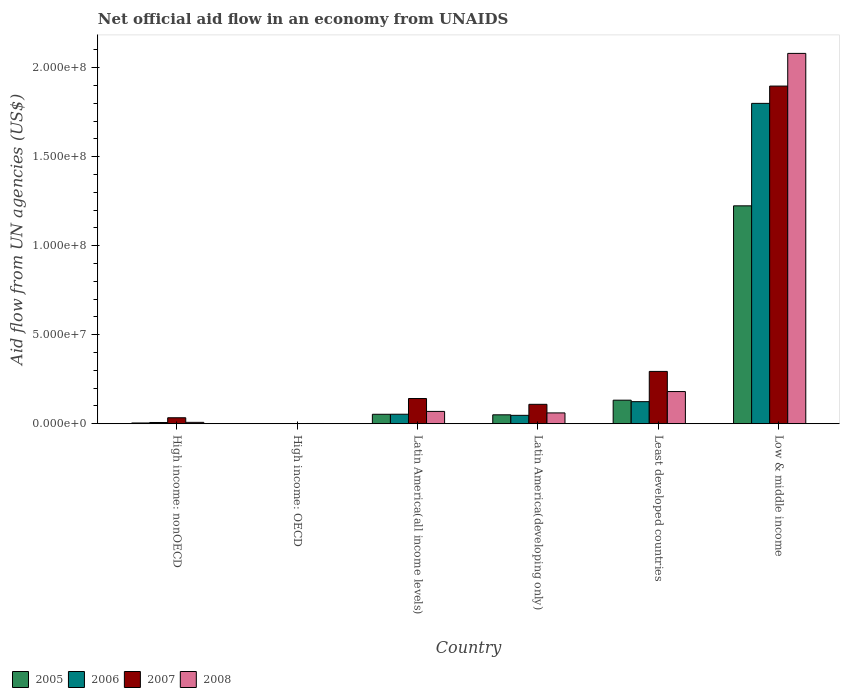Are the number of bars on each tick of the X-axis equal?
Your answer should be compact. Yes. How many bars are there on the 2nd tick from the left?
Your response must be concise. 4. How many bars are there on the 2nd tick from the right?
Give a very brief answer. 4. What is the label of the 3rd group of bars from the left?
Make the answer very short. Latin America(all income levels). Across all countries, what is the maximum net official aid flow in 2005?
Offer a very short reply. 1.22e+08. In which country was the net official aid flow in 2005 maximum?
Your answer should be very brief. Low & middle income. In which country was the net official aid flow in 2008 minimum?
Offer a terse response. High income: OECD. What is the total net official aid flow in 2008 in the graph?
Your answer should be very brief. 2.40e+08. What is the difference between the net official aid flow in 2008 in High income: nonOECD and that in Latin America(developing only)?
Ensure brevity in your answer.  -5.30e+06. What is the difference between the net official aid flow in 2008 in Low & middle income and the net official aid flow in 2006 in Least developed countries?
Offer a terse response. 1.96e+08. What is the average net official aid flow in 2006 per country?
Give a very brief answer. 3.39e+07. What is the difference between the net official aid flow of/in 2006 and net official aid flow of/in 2008 in Latin America(all income levels)?
Your answer should be very brief. -1.58e+06. What is the ratio of the net official aid flow in 2005 in High income: OECD to that in High income: nonOECD?
Your answer should be compact. 0.19. Is the net official aid flow in 2007 in Latin America(developing only) less than that in Least developed countries?
Your answer should be very brief. Yes. What is the difference between the highest and the second highest net official aid flow in 2008?
Make the answer very short. 1.90e+08. What is the difference between the highest and the lowest net official aid flow in 2005?
Ensure brevity in your answer.  1.22e+08. Is the sum of the net official aid flow in 2005 in High income: nonOECD and Least developed countries greater than the maximum net official aid flow in 2006 across all countries?
Offer a terse response. No. Is it the case that in every country, the sum of the net official aid flow in 2005 and net official aid flow in 2007 is greater than the sum of net official aid flow in 2008 and net official aid flow in 2006?
Keep it short and to the point. No. What does the 2nd bar from the left in High income: nonOECD represents?
Provide a short and direct response. 2006. Is it the case that in every country, the sum of the net official aid flow in 2008 and net official aid flow in 2007 is greater than the net official aid flow in 2005?
Offer a terse response. Yes. Are the values on the major ticks of Y-axis written in scientific E-notation?
Offer a very short reply. Yes. Does the graph contain grids?
Offer a terse response. No. Where does the legend appear in the graph?
Keep it short and to the point. Bottom left. How many legend labels are there?
Ensure brevity in your answer.  4. How are the legend labels stacked?
Provide a succinct answer. Horizontal. What is the title of the graph?
Make the answer very short. Net official aid flow in an economy from UNAIDS. Does "1976" appear as one of the legend labels in the graph?
Offer a very short reply. No. What is the label or title of the Y-axis?
Provide a short and direct response. Aid flow from UN agencies (US$). What is the Aid flow from UN agencies (US$) in 2007 in High income: nonOECD?
Keep it short and to the point. 3.36e+06. What is the Aid flow from UN agencies (US$) of 2008 in High income: nonOECD?
Offer a very short reply. 7.80e+05. What is the Aid flow from UN agencies (US$) in 2007 in High income: OECD?
Make the answer very short. 7.00e+04. What is the Aid flow from UN agencies (US$) of 2008 in High income: OECD?
Give a very brief answer. 1.40e+05. What is the Aid flow from UN agencies (US$) in 2005 in Latin America(all income levels)?
Give a very brief answer. 5.32e+06. What is the Aid flow from UN agencies (US$) in 2006 in Latin America(all income levels)?
Ensure brevity in your answer.  5.34e+06. What is the Aid flow from UN agencies (US$) of 2007 in Latin America(all income levels)?
Your response must be concise. 1.42e+07. What is the Aid flow from UN agencies (US$) in 2008 in Latin America(all income levels)?
Provide a succinct answer. 6.92e+06. What is the Aid flow from UN agencies (US$) in 2005 in Latin America(developing only)?
Provide a succinct answer. 5.01e+06. What is the Aid flow from UN agencies (US$) of 2006 in Latin America(developing only)?
Offer a terse response. 4.72e+06. What is the Aid flow from UN agencies (US$) of 2007 in Latin America(developing only)?
Provide a short and direct response. 1.09e+07. What is the Aid flow from UN agencies (US$) in 2008 in Latin America(developing only)?
Your answer should be very brief. 6.08e+06. What is the Aid flow from UN agencies (US$) in 2005 in Least developed countries?
Keep it short and to the point. 1.32e+07. What is the Aid flow from UN agencies (US$) of 2006 in Least developed countries?
Offer a very short reply. 1.24e+07. What is the Aid flow from UN agencies (US$) in 2007 in Least developed countries?
Keep it short and to the point. 2.94e+07. What is the Aid flow from UN agencies (US$) of 2008 in Least developed countries?
Provide a succinct answer. 1.81e+07. What is the Aid flow from UN agencies (US$) of 2005 in Low & middle income?
Give a very brief answer. 1.22e+08. What is the Aid flow from UN agencies (US$) in 2006 in Low & middle income?
Give a very brief answer. 1.80e+08. What is the Aid flow from UN agencies (US$) of 2007 in Low & middle income?
Make the answer very short. 1.90e+08. What is the Aid flow from UN agencies (US$) in 2008 in Low & middle income?
Your answer should be very brief. 2.08e+08. Across all countries, what is the maximum Aid flow from UN agencies (US$) of 2005?
Provide a short and direct response. 1.22e+08. Across all countries, what is the maximum Aid flow from UN agencies (US$) in 2006?
Your answer should be compact. 1.80e+08. Across all countries, what is the maximum Aid flow from UN agencies (US$) of 2007?
Provide a succinct answer. 1.90e+08. Across all countries, what is the maximum Aid flow from UN agencies (US$) in 2008?
Your response must be concise. 2.08e+08. Across all countries, what is the minimum Aid flow from UN agencies (US$) in 2005?
Your answer should be very brief. 8.00e+04. Across all countries, what is the minimum Aid flow from UN agencies (US$) of 2007?
Provide a short and direct response. 7.00e+04. Across all countries, what is the minimum Aid flow from UN agencies (US$) in 2008?
Ensure brevity in your answer.  1.40e+05. What is the total Aid flow from UN agencies (US$) in 2005 in the graph?
Give a very brief answer. 1.46e+08. What is the total Aid flow from UN agencies (US$) in 2006 in the graph?
Your answer should be very brief. 2.03e+08. What is the total Aid flow from UN agencies (US$) of 2007 in the graph?
Offer a very short reply. 2.48e+08. What is the total Aid flow from UN agencies (US$) in 2008 in the graph?
Your answer should be compact. 2.40e+08. What is the difference between the Aid flow from UN agencies (US$) in 2005 in High income: nonOECD and that in High income: OECD?
Offer a very short reply. 3.50e+05. What is the difference between the Aid flow from UN agencies (US$) of 2006 in High income: nonOECD and that in High income: OECD?
Provide a short and direct response. 6.70e+05. What is the difference between the Aid flow from UN agencies (US$) in 2007 in High income: nonOECD and that in High income: OECD?
Your response must be concise. 3.29e+06. What is the difference between the Aid flow from UN agencies (US$) of 2008 in High income: nonOECD and that in High income: OECD?
Provide a short and direct response. 6.40e+05. What is the difference between the Aid flow from UN agencies (US$) of 2005 in High income: nonOECD and that in Latin America(all income levels)?
Provide a succinct answer. -4.89e+06. What is the difference between the Aid flow from UN agencies (US$) of 2006 in High income: nonOECD and that in Latin America(all income levels)?
Provide a short and direct response. -4.64e+06. What is the difference between the Aid flow from UN agencies (US$) of 2007 in High income: nonOECD and that in Latin America(all income levels)?
Provide a short and direct response. -1.08e+07. What is the difference between the Aid flow from UN agencies (US$) in 2008 in High income: nonOECD and that in Latin America(all income levels)?
Offer a very short reply. -6.14e+06. What is the difference between the Aid flow from UN agencies (US$) in 2005 in High income: nonOECD and that in Latin America(developing only)?
Your response must be concise. -4.58e+06. What is the difference between the Aid flow from UN agencies (US$) of 2006 in High income: nonOECD and that in Latin America(developing only)?
Your answer should be compact. -4.02e+06. What is the difference between the Aid flow from UN agencies (US$) of 2007 in High income: nonOECD and that in Latin America(developing only)?
Ensure brevity in your answer.  -7.55e+06. What is the difference between the Aid flow from UN agencies (US$) of 2008 in High income: nonOECD and that in Latin America(developing only)?
Your response must be concise. -5.30e+06. What is the difference between the Aid flow from UN agencies (US$) in 2005 in High income: nonOECD and that in Least developed countries?
Ensure brevity in your answer.  -1.28e+07. What is the difference between the Aid flow from UN agencies (US$) of 2006 in High income: nonOECD and that in Least developed countries?
Provide a short and direct response. -1.17e+07. What is the difference between the Aid flow from UN agencies (US$) in 2007 in High income: nonOECD and that in Least developed countries?
Your answer should be very brief. -2.60e+07. What is the difference between the Aid flow from UN agencies (US$) of 2008 in High income: nonOECD and that in Least developed countries?
Your answer should be very brief. -1.73e+07. What is the difference between the Aid flow from UN agencies (US$) in 2005 in High income: nonOECD and that in Low & middle income?
Ensure brevity in your answer.  -1.22e+08. What is the difference between the Aid flow from UN agencies (US$) in 2006 in High income: nonOECD and that in Low & middle income?
Your response must be concise. -1.79e+08. What is the difference between the Aid flow from UN agencies (US$) of 2007 in High income: nonOECD and that in Low & middle income?
Keep it short and to the point. -1.86e+08. What is the difference between the Aid flow from UN agencies (US$) in 2008 in High income: nonOECD and that in Low & middle income?
Provide a succinct answer. -2.07e+08. What is the difference between the Aid flow from UN agencies (US$) in 2005 in High income: OECD and that in Latin America(all income levels)?
Your answer should be compact. -5.24e+06. What is the difference between the Aid flow from UN agencies (US$) in 2006 in High income: OECD and that in Latin America(all income levels)?
Your response must be concise. -5.31e+06. What is the difference between the Aid flow from UN agencies (US$) in 2007 in High income: OECD and that in Latin America(all income levels)?
Offer a very short reply. -1.41e+07. What is the difference between the Aid flow from UN agencies (US$) in 2008 in High income: OECD and that in Latin America(all income levels)?
Your answer should be very brief. -6.78e+06. What is the difference between the Aid flow from UN agencies (US$) of 2005 in High income: OECD and that in Latin America(developing only)?
Provide a succinct answer. -4.93e+06. What is the difference between the Aid flow from UN agencies (US$) of 2006 in High income: OECD and that in Latin America(developing only)?
Your response must be concise. -4.69e+06. What is the difference between the Aid flow from UN agencies (US$) of 2007 in High income: OECD and that in Latin America(developing only)?
Offer a terse response. -1.08e+07. What is the difference between the Aid flow from UN agencies (US$) in 2008 in High income: OECD and that in Latin America(developing only)?
Provide a short and direct response. -5.94e+06. What is the difference between the Aid flow from UN agencies (US$) in 2005 in High income: OECD and that in Least developed countries?
Provide a succinct answer. -1.32e+07. What is the difference between the Aid flow from UN agencies (US$) of 2006 in High income: OECD and that in Least developed countries?
Your answer should be compact. -1.24e+07. What is the difference between the Aid flow from UN agencies (US$) of 2007 in High income: OECD and that in Least developed countries?
Give a very brief answer. -2.93e+07. What is the difference between the Aid flow from UN agencies (US$) in 2008 in High income: OECD and that in Least developed countries?
Provide a succinct answer. -1.79e+07. What is the difference between the Aid flow from UN agencies (US$) in 2005 in High income: OECD and that in Low & middle income?
Provide a short and direct response. -1.22e+08. What is the difference between the Aid flow from UN agencies (US$) of 2006 in High income: OECD and that in Low & middle income?
Offer a very short reply. -1.80e+08. What is the difference between the Aid flow from UN agencies (US$) of 2007 in High income: OECD and that in Low & middle income?
Provide a short and direct response. -1.90e+08. What is the difference between the Aid flow from UN agencies (US$) in 2008 in High income: OECD and that in Low & middle income?
Provide a short and direct response. -2.08e+08. What is the difference between the Aid flow from UN agencies (US$) in 2006 in Latin America(all income levels) and that in Latin America(developing only)?
Keep it short and to the point. 6.20e+05. What is the difference between the Aid flow from UN agencies (US$) of 2007 in Latin America(all income levels) and that in Latin America(developing only)?
Make the answer very short. 3.25e+06. What is the difference between the Aid flow from UN agencies (US$) of 2008 in Latin America(all income levels) and that in Latin America(developing only)?
Keep it short and to the point. 8.40e+05. What is the difference between the Aid flow from UN agencies (US$) in 2005 in Latin America(all income levels) and that in Least developed countries?
Keep it short and to the point. -7.91e+06. What is the difference between the Aid flow from UN agencies (US$) of 2006 in Latin America(all income levels) and that in Least developed countries?
Keep it short and to the point. -7.06e+06. What is the difference between the Aid flow from UN agencies (US$) in 2007 in Latin America(all income levels) and that in Least developed countries?
Offer a very short reply. -1.52e+07. What is the difference between the Aid flow from UN agencies (US$) in 2008 in Latin America(all income levels) and that in Least developed countries?
Offer a very short reply. -1.12e+07. What is the difference between the Aid flow from UN agencies (US$) of 2005 in Latin America(all income levels) and that in Low & middle income?
Give a very brief answer. -1.17e+08. What is the difference between the Aid flow from UN agencies (US$) of 2006 in Latin America(all income levels) and that in Low & middle income?
Ensure brevity in your answer.  -1.75e+08. What is the difference between the Aid flow from UN agencies (US$) in 2007 in Latin America(all income levels) and that in Low & middle income?
Your response must be concise. -1.76e+08. What is the difference between the Aid flow from UN agencies (US$) in 2008 in Latin America(all income levels) and that in Low & middle income?
Your response must be concise. -2.01e+08. What is the difference between the Aid flow from UN agencies (US$) in 2005 in Latin America(developing only) and that in Least developed countries?
Your response must be concise. -8.22e+06. What is the difference between the Aid flow from UN agencies (US$) of 2006 in Latin America(developing only) and that in Least developed countries?
Provide a succinct answer. -7.68e+06. What is the difference between the Aid flow from UN agencies (US$) of 2007 in Latin America(developing only) and that in Least developed countries?
Keep it short and to the point. -1.85e+07. What is the difference between the Aid flow from UN agencies (US$) in 2008 in Latin America(developing only) and that in Least developed countries?
Offer a very short reply. -1.20e+07. What is the difference between the Aid flow from UN agencies (US$) of 2005 in Latin America(developing only) and that in Low & middle income?
Give a very brief answer. -1.17e+08. What is the difference between the Aid flow from UN agencies (US$) in 2006 in Latin America(developing only) and that in Low & middle income?
Provide a short and direct response. -1.75e+08. What is the difference between the Aid flow from UN agencies (US$) in 2007 in Latin America(developing only) and that in Low & middle income?
Provide a succinct answer. -1.79e+08. What is the difference between the Aid flow from UN agencies (US$) in 2008 in Latin America(developing only) and that in Low & middle income?
Your answer should be very brief. -2.02e+08. What is the difference between the Aid flow from UN agencies (US$) in 2005 in Least developed countries and that in Low & middle income?
Ensure brevity in your answer.  -1.09e+08. What is the difference between the Aid flow from UN agencies (US$) in 2006 in Least developed countries and that in Low & middle income?
Provide a short and direct response. -1.68e+08. What is the difference between the Aid flow from UN agencies (US$) in 2007 in Least developed countries and that in Low & middle income?
Keep it short and to the point. -1.60e+08. What is the difference between the Aid flow from UN agencies (US$) in 2008 in Least developed countries and that in Low & middle income?
Offer a terse response. -1.90e+08. What is the difference between the Aid flow from UN agencies (US$) in 2005 in High income: nonOECD and the Aid flow from UN agencies (US$) in 2006 in High income: OECD?
Your response must be concise. 4.00e+05. What is the difference between the Aid flow from UN agencies (US$) of 2005 in High income: nonOECD and the Aid flow from UN agencies (US$) of 2008 in High income: OECD?
Make the answer very short. 2.90e+05. What is the difference between the Aid flow from UN agencies (US$) of 2006 in High income: nonOECD and the Aid flow from UN agencies (US$) of 2007 in High income: OECD?
Provide a succinct answer. 6.30e+05. What is the difference between the Aid flow from UN agencies (US$) of 2006 in High income: nonOECD and the Aid flow from UN agencies (US$) of 2008 in High income: OECD?
Make the answer very short. 5.60e+05. What is the difference between the Aid flow from UN agencies (US$) in 2007 in High income: nonOECD and the Aid flow from UN agencies (US$) in 2008 in High income: OECD?
Offer a terse response. 3.22e+06. What is the difference between the Aid flow from UN agencies (US$) of 2005 in High income: nonOECD and the Aid flow from UN agencies (US$) of 2006 in Latin America(all income levels)?
Provide a succinct answer. -4.91e+06. What is the difference between the Aid flow from UN agencies (US$) of 2005 in High income: nonOECD and the Aid flow from UN agencies (US$) of 2007 in Latin America(all income levels)?
Your response must be concise. -1.37e+07. What is the difference between the Aid flow from UN agencies (US$) of 2005 in High income: nonOECD and the Aid flow from UN agencies (US$) of 2008 in Latin America(all income levels)?
Provide a short and direct response. -6.49e+06. What is the difference between the Aid flow from UN agencies (US$) in 2006 in High income: nonOECD and the Aid flow from UN agencies (US$) in 2007 in Latin America(all income levels)?
Provide a short and direct response. -1.35e+07. What is the difference between the Aid flow from UN agencies (US$) in 2006 in High income: nonOECD and the Aid flow from UN agencies (US$) in 2008 in Latin America(all income levels)?
Offer a very short reply. -6.22e+06. What is the difference between the Aid flow from UN agencies (US$) in 2007 in High income: nonOECD and the Aid flow from UN agencies (US$) in 2008 in Latin America(all income levels)?
Your response must be concise. -3.56e+06. What is the difference between the Aid flow from UN agencies (US$) of 2005 in High income: nonOECD and the Aid flow from UN agencies (US$) of 2006 in Latin America(developing only)?
Ensure brevity in your answer.  -4.29e+06. What is the difference between the Aid flow from UN agencies (US$) of 2005 in High income: nonOECD and the Aid flow from UN agencies (US$) of 2007 in Latin America(developing only)?
Give a very brief answer. -1.05e+07. What is the difference between the Aid flow from UN agencies (US$) of 2005 in High income: nonOECD and the Aid flow from UN agencies (US$) of 2008 in Latin America(developing only)?
Make the answer very short. -5.65e+06. What is the difference between the Aid flow from UN agencies (US$) in 2006 in High income: nonOECD and the Aid flow from UN agencies (US$) in 2007 in Latin America(developing only)?
Provide a succinct answer. -1.02e+07. What is the difference between the Aid flow from UN agencies (US$) of 2006 in High income: nonOECD and the Aid flow from UN agencies (US$) of 2008 in Latin America(developing only)?
Your answer should be very brief. -5.38e+06. What is the difference between the Aid flow from UN agencies (US$) of 2007 in High income: nonOECD and the Aid flow from UN agencies (US$) of 2008 in Latin America(developing only)?
Keep it short and to the point. -2.72e+06. What is the difference between the Aid flow from UN agencies (US$) in 2005 in High income: nonOECD and the Aid flow from UN agencies (US$) in 2006 in Least developed countries?
Ensure brevity in your answer.  -1.20e+07. What is the difference between the Aid flow from UN agencies (US$) of 2005 in High income: nonOECD and the Aid flow from UN agencies (US$) of 2007 in Least developed countries?
Offer a terse response. -2.90e+07. What is the difference between the Aid flow from UN agencies (US$) in 2005 in High income: nonOECD and the Aid flow from UN agencies (US$) in 2008 in Least developed countries?
Provide a succinct answer. -1.76e+07. What is the difference between the Aid flow from UN agencies (US$) in 2006 in High income: nonOECD and the Aid flow from UN agencies (US$) in 2007 in Least developed countries?
Ensure brevity in your answer.  -2.87e+07. What is the difference between the Aid flow from UN agencies (US$) in 2006 in High income: nonOECD and the Aid flow from UN agencies (US$) in 2008 in Least developed countries?
Provide a short and direct response. -1.74e+07. What is the difference between the Aid flow from UN agencies (US$) of 2007 in High income: nonOECD and the Aid flow from UN agencies (US$) of 2008 in Least developed countries?
Provide a short and direct response. -1.47e+07. What is the difference between the Aid flow from UN agencies (US$) of 2005 in High income: nonOECD and the Aid flow from UN agencies (US$) of 2006 in Low & middle income?
Give a very brief answer. -1.80e+08. What is the difference between the Aid flow from UN agencies (US$) of 2005 in High income: nonOECD and the Aid flow from UN agencies (US$) of 2007 in Low & middle income?
Your answer should be very brief. -1.89e+08. What is the difference between the Aid flow from UN agencies (US$) of 2005 in High income: nonOECD and the Aid flow from UN agencies (US$) of 2008 in Low & middle income?
Provide a short and direct response. -2.08e+08. What is the difference between the Aid flow from UN agencies (US$) of 2006 in High income: nonOECD and the Aid flow from UN agencies (US$) of 2007 in Low & middle income?
Ensure brevity in your answer.  -1.89e+08. What is the difference between the Aid flow from UN agencies (US$) in 2006 in High income: nonOECD and the Aid flow from UN agencies (US$) in 2008 in Low & middle income?
Provide a short and direct response. -2.07e+08. What is the difference between the Aid flow from UN agencies (US$) in 2007 in High income: nonOECD and the Aid flow from UN agencies (US$) in 2008 in Low & middle income?
Make the answer very short. -2.05e+08. What is the difference between the Aid flow from UN agencies (US$) of 2005 in High income: OECD and the Aid flow from UN agencies (US$) of 2006 in Latin America(all income levels)?
Make the answer very short. -5.26e+06. What is the difference between the Aid flow from UN agencies (US$) in 2005 in High income: OECD and the Aid flow from UN agencies (US$) in 2007 in Latin America(all income levels)?
Offer a very short reply. -1.41e+07. What is the difference between the Aid flow from UN agencies (US$) in 2005 in High income: OECD and the Aid flow from UN agencies (US$) in 2008 in Latin America(all income levels)?
Ensure brevity in your answer.  -6.84e+06. What is the difference between the Aid flow from UN agencies (US$) in 2006 in High income: OECD and the Aid flow from UN agencies (US$) in 2007 in Latin America(all income levels)?
Your answer should be very brief. -1.41e+07. What is the difference between the Aid flow from UN agencies (US$) of 2006 in High income: OECD and the Aid flow from UN agencies (US$) of 2008 in Latin America(all income levels)?
Your answer should be compact. -6.89e+06. What is the difference between the Aid flow from UN agencies (US$) of 2007 in High income: OECD and the Aid flow from UN agencies (US$) of 2008 in Latin America(all income levels)?
Give a very brief answer. -6.85e+06. What is the difference between the Aid flow from UN agencies (US$) of 2005 in High income: OECD and the Aid flow from UN agencies (US$) of 2006 in Latin America(developing only)?
Make the answer very short. -4.64e+06. What is the difference between the Aid flow from UN agencies (US$) in 2005 in High income: OECD and the Aid flow from UN agencies (US$) in 2007 in Latin America(developing only)?
Provide a succinct answer. -1.08e+07. What is the difference between the Aid flow from UN agencies (US$) in 2005 in High income: OECD and the Aid flow from UN agencies (US$) in 2008 in Latin America(developing only)?
Provide a succinct answer. -6.00e+06. What is the difference between the Aid flow from UN agencies (US$) of 2006 in High income: OECD and the Aid flow from UN agencies (US$) of 2007 in Latin America(developing only)?
Your response must be concise. -1.09e+07. What is the difference between the Aid flow from UN agencies (US$) in 2006 in High income: OECD and the Aid flow from UN agencies (US$) in 2008 in Latin America(developing only)?
Offer a very short reply. -6.05e+06. What is the difference between the Aid flow from UN agencies (US$) of 2007 in High income: OECD and the Aid flow from UN agencies (US$) of 2008 in Latin America(developing only)?
Your response must be concise. -6.01e+06. What is the difference between the Aid flow from UN agencies (US$) of 2005 in High income: OECD and the Aid flow from UN agencies (US$) of 2006 in Least developed countries?
Your response must be concise. -1.23e+07. What is the difference between the Aid flow from UN agencies (US$) in 2005 in High income: OECD and the Aid flow from UN agencies (US$) in 2007 in Least developed countries?
Make the answer very short. -2.93e+07. What is the difference between the Aid flow from UN agencies (US$) of 2005 in High income: OECD and the Aid flow from UN agencies (US$) of 2008 in Least developed countries?
Offer a very short reply. -1.80e+07. What is the difference between the Aid flow from UN agencies (US$) of 2006 in High income: OECD and the Aid flow from UN agencies (US$) of 2007 in Least developed countries?
Keep it short and to the point. -2.94e+07. What is the difference between the Aid flow from UN agencies (US$) of 2006 in High income: OECD and the Aid flow from UN agencies (US$) of 2008 in Least developed countries?
Provide a succinct answer. -1.80e+07. What is the difference between the Aid flow from UN agencies (US$) in 2007 in High income: OECD and the Aid flow from UN agencies (US$) in 2008 in Least developed countries?
Your response must be concise. -1.80e+07. What is the difference between the Aid flow from UN agencies (US$) of 2005 in High income: OECD and the Aid flow from UN agencies (US$) of 2006 in Low & middle income?
Keep it short and to the point. -1.80e+08. What is the difference between the Aid flow from UN agencies (US$) in 2005 in High income: OECD and the Aid flow from UN agencies (US$) in 2007 in Low & middle income?
Provide a succinct answer. -1.90e+08. What is the difference between the Aid flow from UN agencies (US$) in 2005 in High income: OECD and the Aid flow from UN agencies (US$) in 2008 in Low & middle income?
Provide a short and direct response. -2.08e+08. What is the difference between the Aid flow from UN agencies (US$) of 2006 in High income: OECD and the Aid flow from UN agencies (US$) of 2007 in Low & middle income?
Your response must be concise. -1.90e+08. What is the difference between the Aid flow from UN agencies (US$) of 2006 in High income: OECD and the Aid flow from UN agencies (US$) of 2008 in Low & middle income?
Keep it short and to the point. -2.08e+08. What is the difference between the Aid flow from UN agencies (US$) in 2007 in High income: OECD and the Aid flow from UN agencies (US$) in 2008 in Low & middle income?
Ensure brevity in your answer.  -2.08e+08. What is the difference between the Aid flow from UN agencies (US$) in 2005 in Latin America(all income levels) and the Aid flow from UN agencies (US$) in 2006 in Latin America(developing only)?
Keep it short and to the point. 6.00e+05. What is the difference between the Aid flow from UN agencies (US$) of 2005 in Latin America(all income levels) and the Aid flow from UN agencies (US$) of 2007 in Latin America(developing only)?
Provide a succinct answer. -5.59e+06. What is the difference between the Aid flow from UN agencies (US$) in 2005 in Latin America(all income levels) and the Aid flow from UN agencies (US$) in 2008 in Latin America(developing only)?
Make the answer very short. -7.60e+05. What is the difference between the Aid flow from UN agencies (US$) in 2006 in Latin America(all income levels) and the Aid flow from UN agencies (US$) in 2007 in Latin America(developing only)?
Keep it short and to the point. -5.57e+06. What is the difference between the Aid flow from UN agencies (US$) in 2006 in Latin America(all income levels) and the Aid flow from UN agencies (US$) in 2008 in Latin America(developing only)?
Ensure brevity in your answer.  -7.40e+05. What is the difference between the Aid flow from UN agencies (US$) of 2007 in Latin America(all income levels) and the Aid flow from UN agencies (US$) of 2008 in Latin America(developing only)?
Give a very brief answer. 8.08e+06. What is the difference between the Aid flow from UN agencies (US$) in 2005 in Latin America(all income levels) and the Aid flow from UN agencies (US$) in 2006 in Least developed countries?
Your response must be concise. -7.08e+06. What is the difference between the Aid flow from UN agencies (US$) in 2005 in Latin America(all income levels) and the Aid flow from UN agencies (US$) in 2007 in Least developed countries?
Make the answer very short. -2.41e+07. What is the difference between the Aid flow from UN agencies (US$) of 2005 in Latin America(all income levels) and the Aid flow from UN agencies (US$) of 2008 in Least developed countries?
Give a very brief answer. -1.28e+07. What is the difference between the Aid flow from UN agencies (US$) in 2006 in Latin America(all income levels) and the Aid flow from UN agencies (US$) in 2007 in Least developed countries?
Keep it short and to the point. -2.40e+07. What is the difference between the Aid flow from UN agencies (US$) in 2006 in Latin America(all income levels) and the Aid flow from UN agencies (US$) in 2008 in Least developed countries?
Give a very brief answer. -1.27e+07. What is the difference between the Aid flow from UN agencies (US$) of 2007 in Latin America(all income levels) and the Aid flow from UN agencies (US$) of 2008 in Least developed countries?
Make the answer very short. -3.92e+06. What is the difference between the Aid flow from UN agencies (US$) of 2005 in Latin America(all income levels) and the Aid flow from UN agencies (US$) of 2006 in Low & middle income?
Offer a very short reply. -1.75e+08. What is the difference between the Aid flow from UN agencies (US$) in 2005 in Latin America(all income levels) and the Aid flow from UN agencies (US$) in 2007 in Low & middle income?
Give a very brief answer. -1.84e+08. What is the difference between the Aid flow from UN agencies (US$) in 2005 in Latin America(all income levels) and the Aid flow from UN agencies (US$) in 2008 in Low & middle income?
Provide a short and direct response. -2.03e+08. What is the difference between the Aid flow from UN agencies (US$) in 2006 in Latin America(all income levels) and the Aid flow from UN agencies (US$) in 2007 in Low & middle income?
Your answer should be compact. -1.84e+08. What is the difference between the Aid flow from UN agencies (US$) of 2006 in Latin America(all income levels) and the Aid flow from UN agencies (US$) of 2008 in Low & middle income?
Keep it short and to the point. -2.03e+08. What is the difference between the Aid flow from UN agencies (US$) in 2007 in Latin America(all income levels) and the Aid flow from UN agencies (US$) in 2008 in Low & middle income?
Give a very brief answer. -1.94e+08. What is the difference between the Aid flow from UN agencies (US$) in 2005 in Latin America(developing only) and the Aid flow from UN agencies (US$) in 2006 in Least developed countries?
Provide a short and direct response. -7.39e+06. What is the difference between the Aid flow from UN agencies (US$) in 2005 in Latin America(developing only) and the Aid flow from UN agencies (US$) in 2007 in Least developed countries?
Provide a short and direct response. -2.44e+07. What is the difference between the Aid flow from UN agencies (US$) in 2005 in Latin America(developing only) and the Aid flow from UN agencies (US$) in 2008 in Least developed countries?
Offer a terse response. -1.31e+07. What is the difference between the Aid flow from UN agencies (US$) of 2006 in Latin America(developing only) and the Aid flow from UN agencies (US$) of 2007 in Least developed countries?
Offer a terse response. -2.47e+07. What is the difference between the Aid flow from UN agencies (US$) of 2006 in Latin America(developing only) and the Aid flow from UN agencies (US$) of 2008 in Least developed countries?
Keep it short and to the point. -1.34e+07. What is the difference between the Aid flow from UN agencies (US$) of 2007 in Latin America(developing only) and the Aid flow from UN agencies (US$) of 2008 in Least developed countries?
Offer a terse response. -7.17e+06. What is the difference between the Aid flow from UN agencies (US$) in 2005 in Latin America(developing only) and the Aid flow from UN agencies (US$) in 2006 in Low & middle income?
Offer a very short reply. -1.75e+08. What is the difference between the Aid flow from UN agencies (US$) in 2005 in Latin America(developing only) and the Aid flow from UN agencies (US$) in 2007 in Low & middle income?
Ensure brevity in your answer.  -1.85e+08. What is the difference between the Aid flow from UN agencies (US$) of 2005 in Latin America(developing only) and the Aid flow from UN agencies (US$) of 2008 in Low & middle income?
Make the answer very short. -2.03e+08. What is the difference between the Aid flow from UN agencies (US$) in 2006 in Latin America(developing only) and the Aid flow from UN agencies (US$) in 2007 in Low & middle income?
Provide a succinct answer. -1.85e+08. What is the difference between the Aid flow from UN agencies (US$) of 2006 in Latin America(developing only) and the Aid flow from UN agencies (US$) of 2008 in Low & middle income?
Ensure brevity in your answer.  -2.03e+08. What is the difference between the Aid flow from UN agencies (US$) of 2007 in Latin America(developing only) and the Aid flow from UN agencies (US$) of 2008 in Low & middle income?
Make the answer very short. -1.97e+08. What is the difference between the Aid flow from UN agencies (US$) of 2005 in Least developed countries and the Aid flow from UN agencies (US$) of 2006 in Low & middle income?
Offer a terse response. -1.67e+08. What is the difference between the Aid flow from UN agencies (US$) in 2005 in Least developed countries and the Aid flow from UN agencies (US$) in 2007 in Low & middle income?
Provide a succinct answer. -1.76e+08. What is the difference between the Aid flow from UN agencies (US$) in 2005 in Least developed countries and the Aid flow from UN agencies (US$) in 2008 in Low & middle income?
Make the answer very short. -1.95e+08. What is the difference between the Aid flow from UN agencies (US$) of 2006 in Least developed countries and the Aid flow from UN agencies (US$) of 2007 in Low & middle income?
Make the answer very short. -1.77e+08. What is the difference between the Aid flow from UN agencies (US$) in 2006 in Least developed countries and the Aid flow from UN agencies (US$) in 2008 in Low & middle income?
Offer a terse response. -1.96e+08. What is the difference between the Aid flow from UN agencies (US$) of 2007 in Least developed countries and the Aid flow from UN agencies (US$) of 2008 in Low & middle income?
Offer a very short reply. -1.79e+08. What is the average Aid flow from UN agencies (US$) in 2005 per country?
Make the answer very short. 2.44e+07. What is the average Aid flow from UN agencies (US$) of 2006 per country?
Your answer should be very brief. 3.39e+07. What is the average Aid flow from UN agencies (US$) of 2007 per country?
Keep it short and to the point. 4.13e+07. What is the average Aid flow from UN agencies (US$) in 2008 per country?
Give a very brief answer. 4.00e+07. What is the difference between the Aid flow from UN agencies (US$) in 2005 and Aid flow from UN agencies (US$) in 2006 in High income: nonOECD?
Your response must be concise. -2.70e+05. What is the difference between the Aid flow from UN agencies (US$) in 2005 and Aid flow from UN agencies (US$) in 2007 in High income: nonOECD?
Your answer should be very brief. -2.93e+06. What is the difference between the Aid flow from UN agencies (US$) of 2005 and Aid flow from UN agencies (US$) of 2008 in High income: nonOECD?
Your answer should be very brief. -3.50e+05. What is the difference between the Aid flow from UN agencies (US$) in 2006 and Aid flow from UN agencies (US$) in 2007 in High income: nonOECD?
Offer a very short reply. -2.66e+06. What is the difference between the Aid flow from UN agencies (US$) in 2007 and Aid flow from UN agencies (US$) in 2008 in High income: nonOECD?
Provide a short and direct response. 2.58e+06. What is the difference between the Aid flow from UN agencies (US$) in 2005 and Aid flow from UN agencies (US$) in 2007 in High income: OECD?
Provide a short and direct response. 10000. What is the difference between the Aid flow from UN agencies (US$) in 2005 and Aid flow from UN agencies (US$) in 2008 in High income: OECD?
Offer a terse response. -6.00e+04. What is the difference between the Aid flow from UN agencies (US$) in 2006 and Aid flow from UN agencies (US$) in 2008 in High income: OECD?
Your answer should be very brief. -1.10e+05. What is the difference between the Aid flow from UN agencies (US$) of 2007 and Aid flow from UN agencies (US$) of 2008 in High income: OECD?
Give a very brief answer. -7.00e+04. What is the difference between the Aid flow from UN agencies (US$) in 2005 and Aid flow from UN agencies (US$) in 2007 in Latin America(all income levels)?
Offer a very short reply. -8.84e+06. What is the difference between the Aid flow from UN agencies (US$) of 2005 and Aid flow from UN agencies (US$) of 2008 in Latin America(all income levels)?
Provide a short and direct response. -1.60e+06. What is the difference between the Aid flow from UN agencies (US$) in 2006 and Aid flow from UN agencies (US$) in 2007 in Latin America(all income levels)?
Keep it short and to the point. -8.82e+06. What is the difference between the Aid flow from UN agencies (US$) in 2006 and Aid flow from UN agencies (US$) in 2008 in Latin America(all income levels)?
Your answer should be very brief. -1.58e+06. What is the difference between the Aid flow from UN agencies (US$) in 2007 and Aid flow from UN agencies (US$) in 2008 in Latin America(all income levels)?
Make the answer very short. 7.24e+06. What is the difference between the Aid flow from UN agencies (US$) in 2005 and Aid flow from UN agencies (US$) in 2006 in Latin America(developing only)?
Provide a short and direct response. 2.90e+05. What is the difference between the Aid flow from UN agencies (US$) in 2005 and Aid flow from UN agencies (US$) in 2007 in Latin America(developing only)?
Provide a short and direct response. -5.90e+06. What is the difference between the Aid flow from UN agencies (US$) of 2005 and Aid flow from UN agencies (US$) of 2008 in Latin America(developing only)?
Provide a succinct answer. -1.07e+06. What is the difference between the Aid flow from UN agencies (US$) in 2006 and Aid flow from UN agencies (US$) in 2007 in Latin America(developing only)?
Provide a short and direct response. -6.19e+06. What is the difference between the Aid flow from UN agencies (US$) of 2006 and Aid flow from UN agencies (US$) of 2008 in Latin America(developing only)?
Offer a very short reply. -1.36e+06. What is the difference between the Aid flow from UN agencies (US$) in 2007 and Aid flow from UN agencies (US$) in 2008 in Latin America(developing only)?
Provide a short and direct response. 4.83e+06. What is the difference between the Aid flow from UN agencies (US$) in 2005 and Aid flow from UN agencies (US$) in 2006 in Least developed countries?
Provide a short and direct response. 8.30e+05. What is the difference between the Aid flow from UN agencies (US$) in 2005 and Aid flow from UN agencies (US$) in 2007 in Least developed countries?
Offer a terse response. -1.62e+07. What is the difference between the Aid flow from UN agencies (US$) in 2005 and Aid flow from UN agencies (US$) in 2008 in Least developed countries?
Make the answer very short. -4.85e+06. What is the difference between the Aid flow from UN agencies (US$) of 2006 and Aid flow from UN agencies (US$) of 2007 in Least developed countries?
Make the answer very short. -1.70e+07. What is the difference between the Aid flow from UN agencies (US$) of 2006 and Aid flow from UN agencies (US$) of 2008 in Least developed countries?
Offer a very short reply. -5.68e+06. What is the difference between the Aid flow from UN agencies (US$) in 2007 and Aid flow from UN agencies (US$) in 2008 in Least developed countries?
Offer a very short reply. 1.13e+07. What is the difference between the Aid flow from UN agencies (US$) in 2005 and Aid flow from UN agencies (US$) in 2006 in Low & middle income?
Provide a succinct answer. -5.76e+07. What is the difference between the Aid flow from UN agencies (US$) in 2005 and Aid flow from UN agencies (US$) in 2007 in Low & middle income?
Your response must be concise. -6.73e+07. What is the difference between the Aid flow from UN agencies (US$) in 2005 and Aid flow from UN agencies (US$) in 2008 in Low & middle income?
Your answer should be compact. -8.56e+07. What is the difference between the Aid flow from UN agencies (US$) of 2006 and Aid flow from UN agencies (US$) of 2007 in Low & middle income?
Provide a short and direct response. -9.71e+06. What is the difference between the Aid flow from UN agencies (US$) in 2006 and Aid flow from UN agencies (US$) in 2008 in Low & middle income?
Your response must be concise. -2.81e+07. What is the difference between the Aid flow from UN agencies (US$) in 2007 and Aid flow from UN agencies (US$) in 2008 in Low & middle income?
Keep it short and to the point. -1.84e+07. What is the ratio of the Aid flow from UN agencies (US$) in 2005 in High income: nonOECD to that in High income: OECD?
Offer a terse response. 5.38. What is the ratio of the Aid flow from UN agencies (US$) of 2006 in High income: nonOECD to that in High income: OECD?
Ensure brevity in your answer.  23.33. What is the ratio of the Aid flow from UN agencies (US$) of 2007 in High income: nonOECD to that in High income: OECD?
Your response must be concise. 48. What is the ratio of the Aid flow from UN agencies (US$) in 2008 in High income: nonOECD to that in High income: OECD?
Give a very brief answer. 5.57. What is the ratio of the Aid flow from UN agencies (US$) in 2005 in High income: nonOECD to that in Latin America(all income levels)?
Keep it short and to the point. 0.08. What is the ratio of the Aid flow from UN agencies (US$) in 2006 in High income: nonOECD to that in Latin America(all income levels)?
Offer a terse response. 0.13. What is the ratio of the Aid flow from UN agencies (US$) in 2007 in High income: nonOECD to that in Latin America(all income levels)?
Offer a very short reply. 0.24. What is the ratio of the Aid flow from UN agencies (US$) in 2008 in High income: nonOECD to that in Latin America(all income levels)?
Offer a very short reply. 0.11. What is the ratio of the Aid flow from UN agencies (US$) of 2005 in High income: nonOECD to that in Latin America(developing only)?
Make the answer very short. 0.09. What is the ratio of the Aid flow from UN agencies (US$) of 2006 in High income: nonOECD to that in Latin America(developing only)?
Provide a succinct answer. 0.15. What is the ratio of the Aid flow from UN agencies (US$) of 2007 in High income: nonOECD to that in Latin America(developing only)?
Give a very brief answer. 0.31. What is the ratio of the Aid flow from UN agencies (US$) in 2008 in High income: nonOECD to that in Latin America(developing only)?
Provide a succinct answer. 0.13. What is the ratio of the Aid flow from UN agencies (US$) in 2005 in High income: nonOECD to that in Least developed countries?
Provide a succinct answer. 0.03. What is the ratio of the Aid flow from UN agencies (US$) in 2006 in High income: nonOECD to that in Least developed countries?
Give a very brief answer. 0.06. What is the ratio of the Aid flow from UN agencies (US$) of 2007 in High income: nonOECD to that in Least developed countries?
Your answer should be very brief. 0.11. What is the ratio of the Aid flow from UN agencies (US$) of 2008 in High income: nonOECD to that in Least developed countries?
Provide a short and direct response. 0.04. What is the ratio of the Aid flow from UN agencies (US$) of 2005 in High income: nonOECD to that in Low & middle income?
Your answer should be very brief. 0. What is the ratio of the Aid flow from UN agencies (US$) in 2006 in High income: nonOECD to that in Low & middle income?
Ensure brevity in your answer.  0. What is the ratio of the Aid flow from UN agencies (US$) in 2007 in High income: nonOECD to that in Low & middle income?
Provide a short and direct response. 0.02. What is the ratio of the Aid flow from UN agencies (US$) of 2008 in High income: nonOECD to that in Low & middle income?
Ensure brevity in your answer.  0. What is the ratio of the Aid flow from UN agencies (US$) in 2005 in High income: OECD to that in Latin America(all income levels)?
Provide a short and direct response. 0.01. What is the ratio of the Aid flow from UN agencies (US$) of 2006 in High income: OECD to that in Latin America(all income levels)?
Provide a short and direct response. 0.01. What is the ratio of the Aid flow from UN agencies (US$) of 2007 in High income: OECD to that in Latin America(all income levels)?
Provide a succinct answer. 0. What is the ratio of the Aid flow from UN agencies (US$) of 2008 in High income: OECD to that in Latin America(all income levels)?
Provide a succinct answer. 0.02. What is the ratio of the Aid flow from UN agencies (US$) of 2005 in High income: OECD to that in Latin America(developing only)?
Offer a terse response. 0.02. What is the ratio of the Aid flow from UN agencies (US$) of 2006 in High income: OECD to that in Latin America(developing only)?
Provide a succinct answer. 0.01. What is the ratio of the Aid flow from UN agencies (US$) of 2007 in High income: OECD to that in Latin America(developing only)?
Give a very brief answer. 0.01. What is the ratio of the Aid flow from UN agencies (US$) in 2008 in High income: OECD to that in Latin America(developing only)?
Your answer should be very brief. 0.02. What is the ratio of the Aid flow from UN agencies (US$) in 2005 in High income: OECD to that in Least developed countries?
Your response must be concise. 0.01. What is the ratio of the Aid flow from UN agencies (US$) in 2006 in High income: OECD to that in Least developed countries?
Your response must be concise. 0. What is the ratio of the Aid flow from UN agencies (US$) of 2007 in High income: OECD to that in Least developed countries?
Provide a succinct answer. 0. What is the ratio of the Aid flow from UN agencies (US$) of 2008 in High income: OECD to that in Least developed countries?
Offer a terse response. 0.01. What is the ratio of the Aid flow from UN agencies (US$) in 2005 in High income: OECD to that in Low & middle income?
Provide a short and direct response. 0. What is the ratio of the Aid flow from UN agencies (US$) in 2006 in High income: OECD to that in Low & middle income?
Keep it short and to the point. 0. What is the ratio of the Aid flow from UN agencies (US$) in 2008 in High income: OECD to that in Low & middle income?
Give a very brief answer. 0. What is the ratio of the Aid flow from UN agencies (US$) of 2005 in Latin America(all income levels) to that in Latin America(developing only)?
Your answer should be compact. 1.06. What is the ratio of the Aid flow from UN agencies (US$) in 2006 in Latin America(all income levels) to that in Latin America(developing only)?
Offer a terse response. 1.13. What is the ratio of the Aid flow from UN agencies (US$) in 2007 in Latin America(all income levels) to that in Latin America(developing only)?
Keep it short and to the point. 1.3. What is the ratio of the Aid flow from UN agencies (US$) of 2008 in Latin America(all income levels) to that in Latin America(developing only)?
Your answer should be compact. 1.14. What is the ratio of the Aid flow from UN agencies (US$) of 2005 in Latin America(all income levels) to that in Least developed countries?
Keep it short and to the point. 0.4. What is the ratio of the Aid flow from UN agencies (US$) of 2006 in Latin America(all income levels) to that in Least developed countries?
Provide a short and direct response. 0.43. What is the ratio of the Aid flow from UN agencies (US$) of 2007 in Latin America(all income levels) to that in Least developed countries?
Keep it short and to the point. 0.48. What is the ratio of the Aid flow from UN agencies (US$) of 2008 in Latin America(all income levels) to that in Least developed countries?
Give a very brief answer. 0.38. What is the ratio of the Aid flow from UN agencies (US$) of 2005 in Latin America(all income levels) to that in Low & middle income?
Offer a very short reply. 0.04. What is the ratio of the Aid flow from UN agencies (US$) of 2006 in Latin America(all income levels) to that in Low & middle income?
Provide a succinct answer. 0.03. What is the ratio of the Aid flow from UN agencies (US$) in 2007 in Latin America(all income levels) to that in Low & middle income?
Make the answer very short. 0.07. What is the ratio of the Aid flow from UN agencies (US$) of 2005 in Latin America(developing only) to that in Least developed countries?
Give a very brief answer. 0.38. What is the ratio of the Aid flow from UN agencies (US$) of 2006 in Latin America(developing only) to that in Least developed countries?
Keep it short and to the point. 0.38. What is the ratio of the Aid flow from UN agencies (US$) of 2007 in Latin America(developing only) to that in Least developed countries?
Offer a very short reply. 0.37. What is the ratio of the Aid flow from UN agencies (US$) of 2008 in Latin America(developing only) to that in Least developed countries?
Your answer should be compact. 0.34. What is the ratio of the Aid flow from UN agencies (US$) in 2005 in Latin America(developing only) to that in Low & middle income?
Your answer should be compact. 0.04. What is the ratio of the Aid flow from UN agencies (US$) of 2006 in Latin America(developing only) to that in Low & middle income?
Your answer should be compact. 0.03. What is the ratio of the Aid flow from UN agencies (US$) in 2007 in Latin America(developing only) to that in Low & middle income?
Offer a very short reply. 0.06. What is the ratio of the Aid flow from UN agencies (US$) in 2008 in Latin America(developing only) to that in Low & middle income?
Provide a succinct answer. 0.03. What is the ratio of the Aid flow from UN agencies (US$) in 2005 in Least developed countries to that in Low & middle income?
Provide a short and direct response. 0.11. What is the ratio of the Aid flow from UN agencies (US$) in 2006 in Least developed countries to that in Low & middle income?
Provide a succinct answer. 0.07. What is the ratio of the Aid flow from UN agencies (US$) of 2007 in Least developed countries to that in Low & middle income?
Your answer should be compact. 0.15. What is the ratio of the Aid flow from UN agencies (US$) of 2008 in Least developed countries to that in Low & middle income?
Offer a very short reply. 0.09. What is the difference between the highest and the second highest Aid flow from UN agencies (US$) of 2005?
Your answer should be compact. 1.09e+08. What is the difference between the highest and the second highest Aid flow from UN agencies (US$) of 2006?
Provide a short and direct response. 1.68e+08. What is the difference between the highest and the second highest Aid flow from UN agencies (US$) in 2007?
Your response must be concise. 1.60e+08. What is the difference between the highest and the second highest Aid flow from UN agencies (US$) in 2008?
Your response must be concise. 1.90e+08. What is the difference between the highest and the lowest Aid flow from UN agencies (US$) of 2005?
Provide a short and direct response. 1.22e+08. What is the difference between the highest and the lowest Aid flow from UN agencies (US$) of 2006?
Keep it short and to the point. 1.80e+08. What is the difference between the highest and the lowest Aid flow from UN agencies (US$) of 2007?
Keep it short and to the point. 1.90e+08. What is the difference between the highest and the lowest Aid flow from UN agencies (US$) in 2008?
Give a very brief answer. 2.08e+08. 